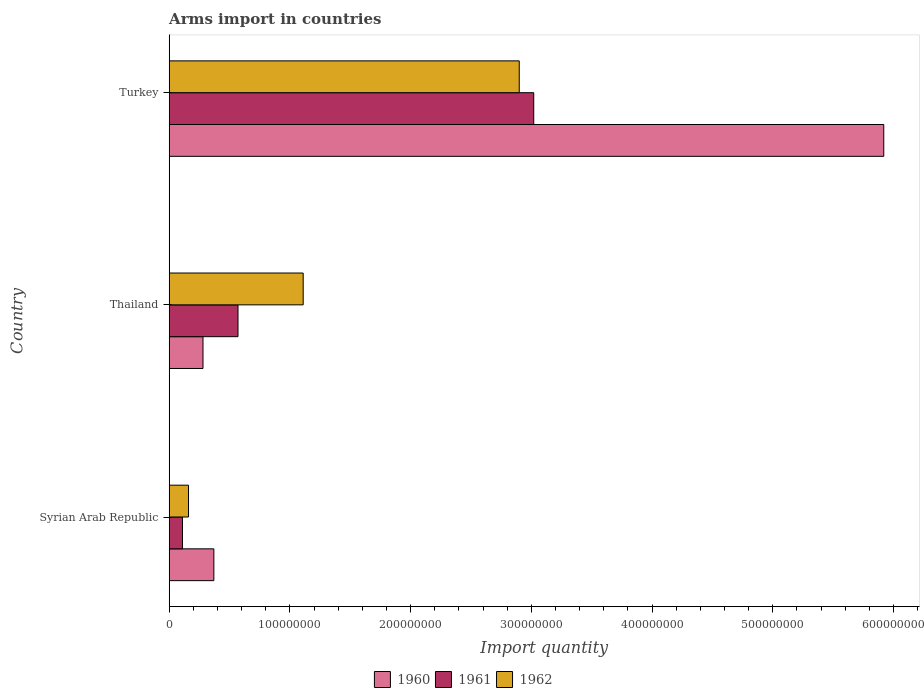How many different coloured bars are there?
Offer a very short reply. 3. How many groups of bars are there?
Keep it short and to the point. 3. Are the number of bars on each tick of the Y-axis equal?
Provide a short and direct response. Yes. How many bars are there on the 3rd tick from the top?
Provide a succinct answer. 3. What is the label of the 2nd group of bars from the top?
Keep it short and to the point. Thailand. In how many cases, is the number of bars for a given country not equal to the number of legend labels?
Your answer should be very brief. 0. What is the total arms import in 1961 in Turkey?
Provide a succinct answer. 3.02e+08. Across all countries, what is the maximum total arms import in 1962?
Ensure brevity in your answer.  2.90e+08. Across all countries, what is the minimum total arms import in 1962?
Give a very brief answer. 1.60e+07. In which country was the total arms import in 1962 minimum?
Make the answer very short. Syrian Arab Republic. What is the total total arms import in 1962 in the graph?
Keep it short and to the point. 4.17e+08. What is the difference between the total arms import in 1960 in Syrian Arab Republic and that in Thailand?
Make the answer very short. 9.00e+06. What is the difference between the total arms import in 1962 in Turkey and the total arms import in 1961 in Syrian Arab Republic?
Offer a terse response. 2.79e+08. What is the average total arms import in 1962 per country?
Offer a very short reply. 1.39e+08. What is the difference between the total arms import in 1960 and total arms import in 1962 in Turkey?
Make the answer very short. 3.02e+08. In how many countries, is the total arms import in 1960 greater than 480000000 ?
Your answer should be compact. 1. What is the ratio of the total arms import in 1962 in Syrian Arab Republic to that in Thailand?
Your answer should be very brief. 0.14. Is the total arms import in 1962 in Syrian Arab Republic less than that in Thailand?
Give a very brief answer. Yes. What is the difference between the highest and the second highest total arms import in 1961?
Provide a succinct answer. 2.45e+08. What is the difference between the highest and the lowest total arms import in 1960?
Offer a very short reply. 5.64e+08. Is the sum of the total arms import in 1961 in Syrian Arab Republic and Turkey greater than the maximum total arms import in 1962 across all countries?
Offer a very short reply. Yes. Are all the bars in the graph horizontal?
Give a very brief answer. Yes. Where does the legend appear in the graph?
Give a very brief answer. Bottom center. What is the title of the graph?
Offer a terse response. Arms import in countries. Does "1964" appear as one of the legend labels in the graph?
Make the answer very short. No. What is the label or title of the X-axis?
Your response must be concise. Import quantity. What is the Import quantity of 1960 in Syrian Arab Republic?
Your response must be concise. 3.70e+07. What is the Import quantity of 1961 in Syrian Arab Republic?
Your response must be concise. 1.10e+07. What is the Import quantity in 1962 in Syrian Arab Republic?
Make the answer very short. 1.60e+07. What is the Import quantity in 1960 in Thailand?
Keep it short and to the point. 2.80e+07. What is the Import quantity of 1961 in Thailand?
Offer a terse response. 5.70e+07. What is the Import quantity in 1962 in Thailand?
Make the answer very short. 1.11e+08. What is the Import quantity of 1960 in Turkey?
Ensure brevity in your answer.  5.92e+08. What is the Import quantity in 1961 in Turkey?
Keep it short and to the point. 3.02e+08. What is the Import quantity of 1962 in Turkey?
Offer a terse response. 2.90e+08. Across all countries, what is the maximum Import quantity in 1960?
Make the answer very short. 5.92e+08. Across all countries, what is the maximum Import quantity of 1961?
Your answer should be very brief. 3.02e+08. Across all countries, what is the maximum Import quantity in 1962?
Ensure brevity in your answer.  2.90e+08. Across all countries, what is the minimum Import quantity of 1960?
Your answer should be very brief. 2.80e+07. Across all countries, what is the minimum Import quantity of 1961?
Your answer should be very brief. 1.10e+07. Across all countries, what is the minimum Import quantity in 1962?
Ensure brevity in your answer.  1.60e+07. What is the total Import quantity of 1960 in the graph?
Make the answer very short. 6.57e+08. What is the total Import quantity in 1961 in the graph?
Provide a short and direct response. 3.70e+08. What is the total Import quantity of 1962 in the graph?
Give a very brief answer. 4.17e+08. What is the difference between the Import quantity in 1960 in Syrian Arab Republic and that in Thailand?
Ensure brevity in your answer.  9.00e+06. What is the difference between the Import quantity of 1961 in Syrian Arab Republic and that in Thailand?
Your answer should be compact. -4.60e+07. What is the difference between the Import quantity in 1962 in Syrian Arab Republic and that in Thailand?
Offer a very short reply. -9.50e+07. What is the difference between the Import quantity of 1960 in Syrian Arab Republic and that in Turkey?
Offer a very short reply. -5.55e+08. What is the difference between the Import quantity of 1961 in Syrian Arab Republic and that in Turkey?
Your answer should be compact. -2.91e+08. What is the difference between the Import quantity of 1962 in Syrian Arab Republic and that in Turkey?
Your answer should be very brief. -2.74e+08. What is the difference between the Import quantity in 1960 in Thailand and that in Turkey?
Offer a terse response. -5.64e+08. What is the difference between the Import quantity of 1961 in Thailand and that in Turkey?
Your answer should be very brief. -2.45e+08. What is the difference between the Import quantity in 1962 in Thailand and that in Turkey?
Keep it short and to the point. -1.79e+08. What is the difference between the Import quantity in 1960 in Syrian Arab Republic and the Import quantity in 1961 in Thailand?
Provide a succinct answer. -2.00e+07. What is the difference between the Import quantity in 1960 in Syrian Arab Republic and the Import quantity in 1962 in Thailand?
Offer a terse response. -7.40e+07. What is the difference between the Import quantity in 1961 in Syrian Arab Republic and the Import quantity in 1962 in Thailand?
Your answer should be very brief. -1.00e+08. What is the difference between the Import quantity in 1960 in Syrian Arab Republic and the Import quantity in 1961 in Turkey?
Offer a very short reply. -2.65e+08. What is the difference between the Import quantity in 1960 in Syrian Arab Republic and the Import quantity in 1962 in Turkey?
Keep it short and to the point. -2.53e+08. What is the difference between the Import quantity in 1961 in Syrian Arab Republic and the Import quantity in 1962 in Turkey?
Provide a short and direct response. -2.79e+08. What is the difference between the Import quantity in 1960 in Thailand and the Import quantity in 1961 in Turkey?
Provide a short and direct response. -2.74e+08. What is the difference between the Import quantity in 1960 in Thailand and the Import quantity in 1962 in Turkey?
Give a very brief answer. -2.62e+08. What is the difference between the Import quantity of 1961 in Thailand and the Import quantity of 1962 in Turkey?
Your answer should be compact. -2.33e+08. What is the average Import quantity of 1960 per country?
Your answer should be compact. 2.19e+08. What is the average Import quantity in 1961 per country?
Give a very brief answer. 1.23e+08. What is the average Import quantity in 1962 per country?
Ensure brevity in your answer.  1.39e+08. What is the difference between the Import quantity in 1960 and Import quantity in 1961 in Syrian Arab Republic?
Make the answer very short. 2.60e+07. What is the difference between the Import quantity in 1960 and Import quantity in 1962 in Syrian Arab Republic?
Your answer should be very brief. 2.10e+07. What is the difference between the Import quantity in 1961 and Import quantity in 1962 in Syrian Arab Republic?
Your answer should be very brief. -5.00e+06. What is the difference between the Import quantity in 1960 and Import quantity in 1961 in Thailand?
Your response must be concise. -2.90e+07. What is the difference between the Import quantity of 1960 and Import quantity of 1962 in Thailand?
Your answer should be very brief. -8.30e+07. What is the difference between the Import quantity of 1961 and Import quantity of 1962 in Thailand?
Offer a very short reply. -5.40e+07. What is the difference between the Import quantity in 1960 and Import quantity in 1961 in Turkey?
Offer a very short reply. 2.90e+08. What is the difference between the Import quantity in 1960 and Import quantity in 1962 in Turkey?
Make the answer very short. 3.02e+08. What is the ratio of the Import quantity of 1960 in Syrian Arab Republic to that in Thailand?
Your response must be concise. 1.32. What is the ratio of the Import quantity of 1961 in Syrian Arab Republic to that in Thailand?
Ensure brevity in your answer.  0.19. What is the ratio of the Import quantity in 1962 in Syrian Arab Republic to that in Thailand?
Offer a terse response. 0.14. What is the ratio of the Import quantity in 1960 in Syrian Arab Republic to that in Turkey?
Offer a terse response. 0.06. What is the ratio of the Import quantity of 1961 in Syrian Arab Republic to that in Turkey?
Give a very brief answer. 0.04. What is the ratio of the Import quantity in 1962 in Syrian Arab Republic to that in Turkey?
Your answer should be very brief. 0.06. What is the ratio of the Import quantity in 1960 in Thailand to that in Turkey?
Offer a very short reply. 0.05. What is the ratio of the Import quantity of 1961 in Thailand to that in Turkey?
Ensure brevity in your answer.  0.19. What is the ratio of the Import quantity of 1962 in Thailand to that in Turkey?
Offer a terse response. 0.38. What is the difference between the highest and the second highest Import quantity of 1960?
Offer a very short reply. 5.55e+08. What is the difference between the highest and the second highest Import quantity in 1961?
Offer a very short reply. 2.45e+08. What is the difference between the highest and the second highest Import quantity of 1962?
Make the answer very short. 1.79e+08. What is the difference between the highest and the lowest Import quantity of 1960?
Offer a terse response. 5.64e+08. What is the difference between the highest and the lowest Import quantity in 1961?
Keep it short and to the point. 2.91e+08. What is the difference between the highest and the lowest Import quantity of 1962?
Offer a terse response. 2.74e+08. 